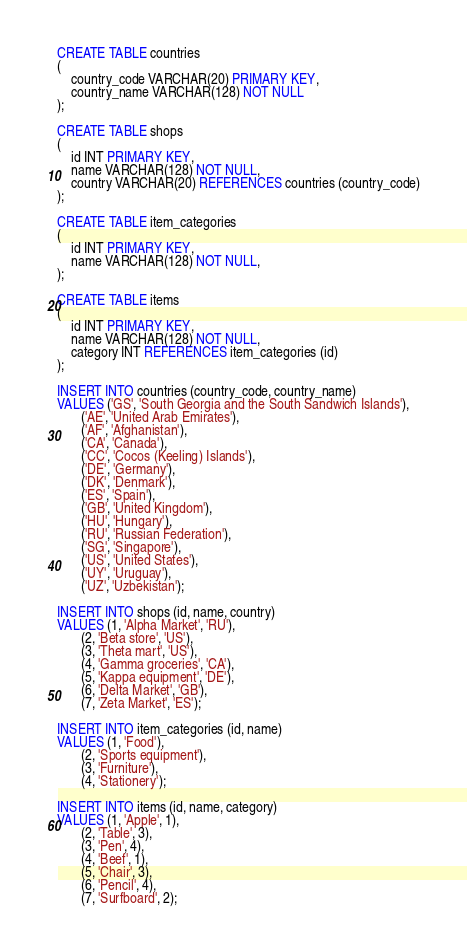<code> <loc_0><loc_0><loc_500><loc_500><_SQL_>CREATE TABLE countries
(
    country_code VARCHAR(20) PRIMARY KEY,
    country_name VARCHAR(128) NOT NULL
);

CREATE TABLE shops
(
    id INT PRIMARY KEY,
    name VARCHAR(128) NOT NULL,
    country VARCHAR(20) REFERENCES countries (country_code)
);

CREATE TABLE item_categories
(
    id INT PRIMARY KEY,
    name VARCHAR(128) NOT NULL,
);

CREATE TABLE items
(
    id INT PRIMARY KEY,
    name VARCHAR(128) NOT NULL,
    category INT REFERENCES item_categories (id)
);

INSERT INTO countries (country_code, country_name)
VALUES ('GS', 'South Georgia and the South Sandwich Islands'),
       ('AE', 'United Arab Emirates'),
       ('AF', 'Afghanistan'),
       ('CA', 'Canada'),
       ('CC', 'Cocos (Keeling) Islands'),
       ('DE', 'Germany'),
       ('DK', 'Denmark'),
       ('ES', 'Spain'),
       ('GB', 'United Kingdom'),
       ('HU', 'Hungary'),
       ('RU', 'Russian Federation'),
       ('SG', 'Singapore'),
       ('US', 'United States'),
       ('UY', 'Uruguay'),
       ('UZ', 'Uzbekistan');

INSERT INTO shops (id, name, country)
VALUES (1, 'Alpha Market', 'RU'),
       (2, 'Beta store', 'US'),
       (3, 'Theta mart', 'US'),
       (4, 'Gamma groceries', 'CA'),
       (5, 'Kappa equipment', 'DE'),
       (6, 'Delta Market', 'GB'),
       (7, 'Zeta Market', 'ES');

INSERT INTO item_categories (id, name)
VALUES (1, 'Food'),
       (2, 'Sports equipment'),
       (3, 'Furniture'),
       (4, 'Stationery');

INSERT INTO items (id, name, category)
VALUES (1, 'Apple', 1),
       (2, 'Table', 3),
       (3, 'Pen', 4),
       (4, 'Beef', 1),
       (5, 'Chair', 3),
       (6, 'Pencil', 4),
       (7, 'Surfboard', 2);</code> 